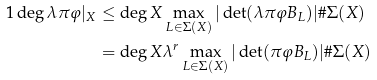Convert formula to latex. <formula><loc_0><loc_0><loc_500><loc_500>1 \deg { \lambda \pi \varphi | _ { X } } & \leq \deg { X } \max _ { L \in \Sigma ( X ) } | \det ( \lambda \pi \varphi B _ { L } ) | \# \Sigma ( X ) \\ & = \deg { X } \lambda ^ { r } \max _ { L \in \Sigma ( X ) } | \det ( \pi \varphi B _ { L } ) | \# \Sigma ( X )</formula> 